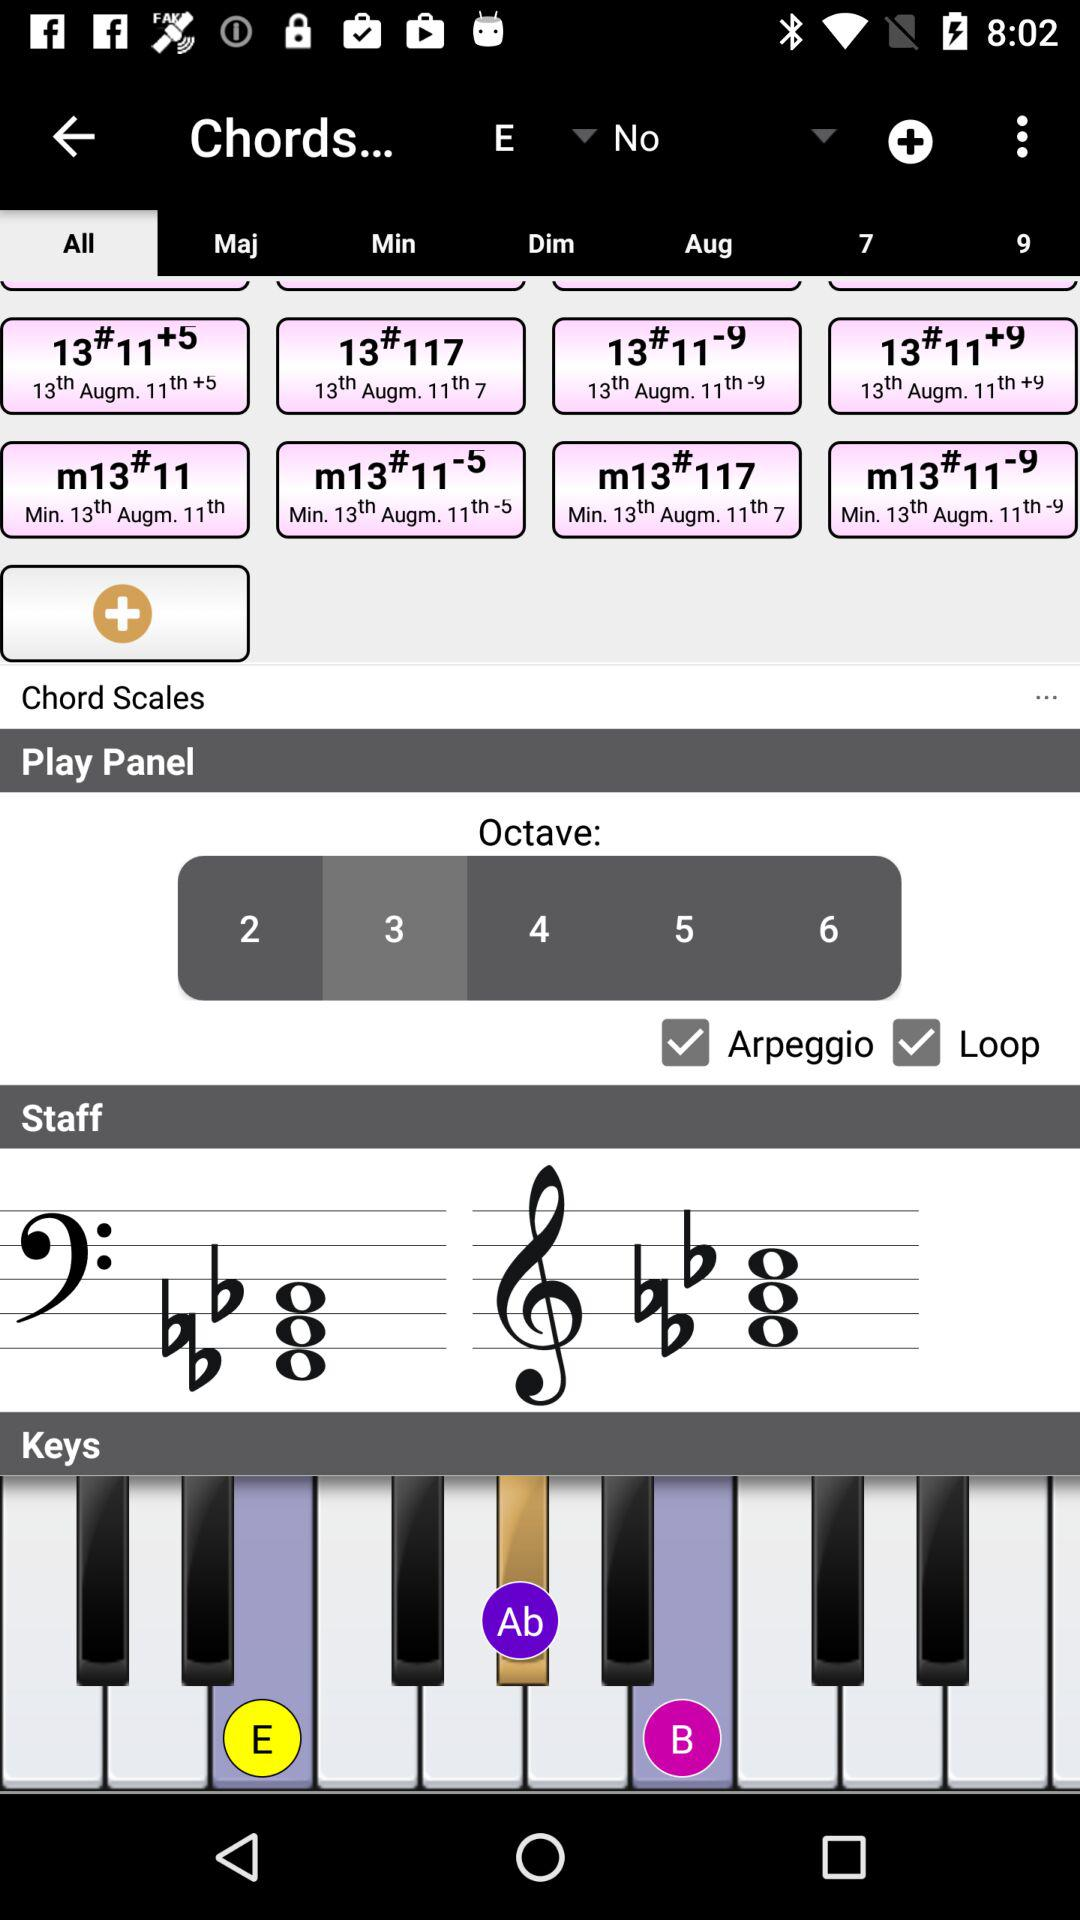What is the selected octave number? The selected octave number on the music application interface is 3. This setting influences the pitch range of the notes played, making them sound lower or higher depending on the selected octave. 